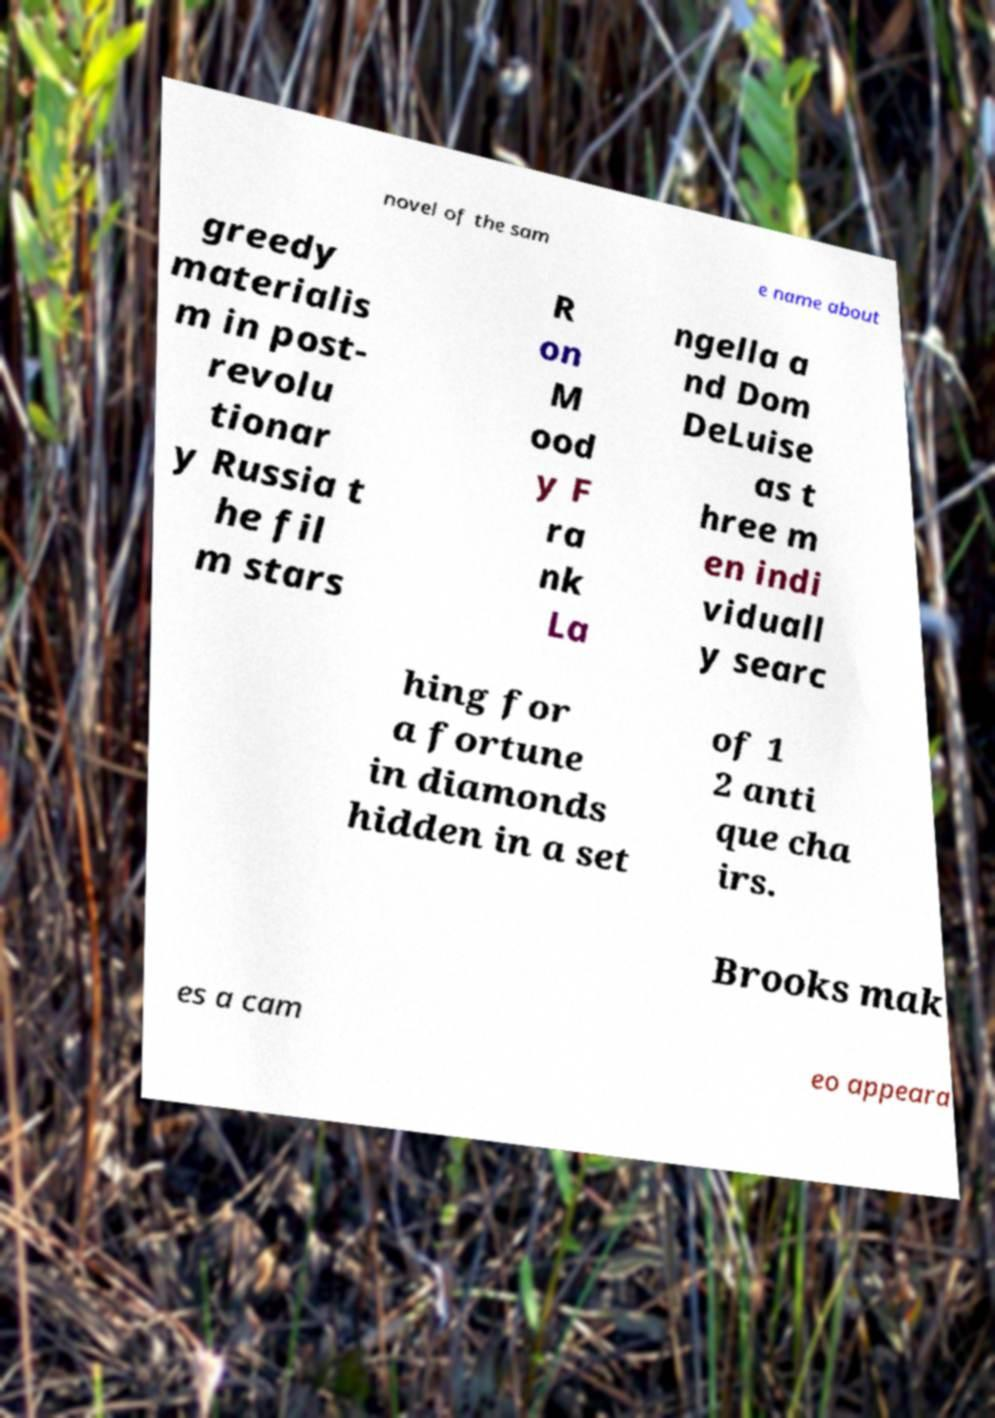Could you assist in decoding the text presented in this image and type it out clearly? novel of the sam e name about greedy materialis m in post- revolu tionar y Russia t he fil m stars R on M ood y F ra nk La ngella a nd Dom DeLuise as t hree m en indi viduall y searc hing for a fortune in diamonds hidden in a set of 1 2 anti que cha irs. Brooks mak es a cam eo appeara 